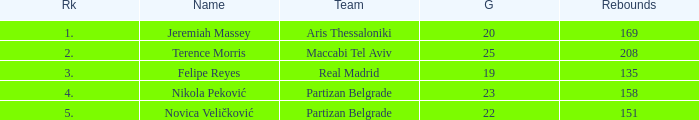What is the number of Games for the Maccabi Tel Aviv Team with less than 208 Rebounds? None. 